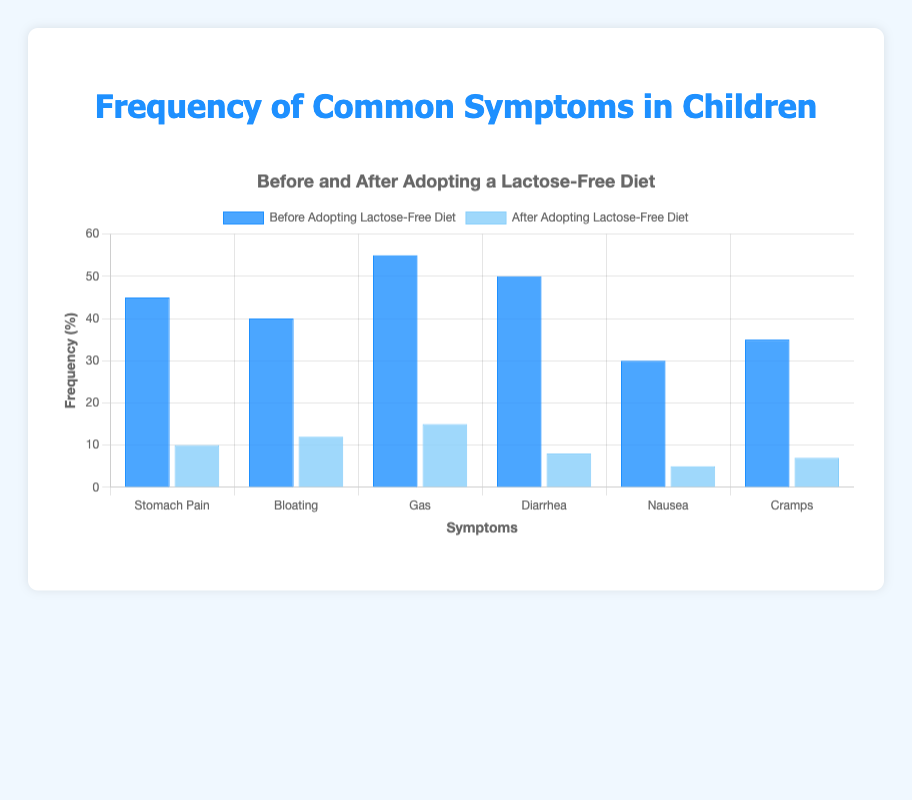What is the frequency difference of "Diarrhea" before and after adopting a lactose-free diet? Before adopting a lactose-free diet, the frequency of Diarrhea is 50. After adopting the diet, it is 8. The difference is 50 - 8 = 42
Answer: 42 Which symptom had the highest reduction in frequency after adopting a lactose-free diet? To find the highest reduction, subtract the "After" frequency from the "Before" frequency for each symptom. The biggest difference is seen in Gas, with a reduction from 55 to 15, a 40-point reduction
Answer: Gas What is the total frequency of symptoms after adopting a lactose-free diet? Sum the frequencies of all symptoms after adopting the diet: 10 (Stomach Pain) + 12 (Bloating) + 15 (Gas) + 8 (Diarrhea) + 5 (Nausea) + 7 (Cramps) = 57
Answer: 57 Is the frequency of "Gas" symptoms greater before or after adopting a lactose-free diet? The frequency of Gas before adopting the diet is 55, and after adopting the diet is 15. Since 55 is greater than 15, the frequency is greater before
Answer: Before How much did the frequency of "Nausea" decrease after adopting a lactose-free diet? The frequency of Nausea before adopting the diet is 30, and after is 5. The decrease is 30 - 5 = 25
Answer: 25 What is the average frequency of symptoms before adopting a lactose-free diet? Sum the frequencies of all symptoms before adopting the diet: 45 (Stomach Pain) + 40 (Bloating) + 55 (Gas) + 50 (Diarrhea) + 30 (Nausea) + 35 (Cramps) = 255, then divide by the number of symptoms (6). The average is 255 / 6 ≈ 42.5
Answer: 42.5 Which symptom showed the least reduction in frequency after adopting a lactose-free diet? Calculate the reduction for each symptom and find the minimum: Stomach Pain (35), Bloating (28), Gas (40), Diarrhea (42), Nausea (25), Cramps (28). The smallest reduction is for Nausea, with a reduction of 25
Answer: Nausea 